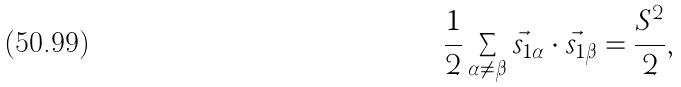<formula> <loc_0><loc_0><loc_500><loc_500>\frac { 1 } { 2 } \sum _ { \alpha \neq \beta } \vec { s } _ { 1 \alpha } \cdot \vec { s } _ { 1 \beta } = \frac { S ^ { 2 } } { 2 } ,</formula> 